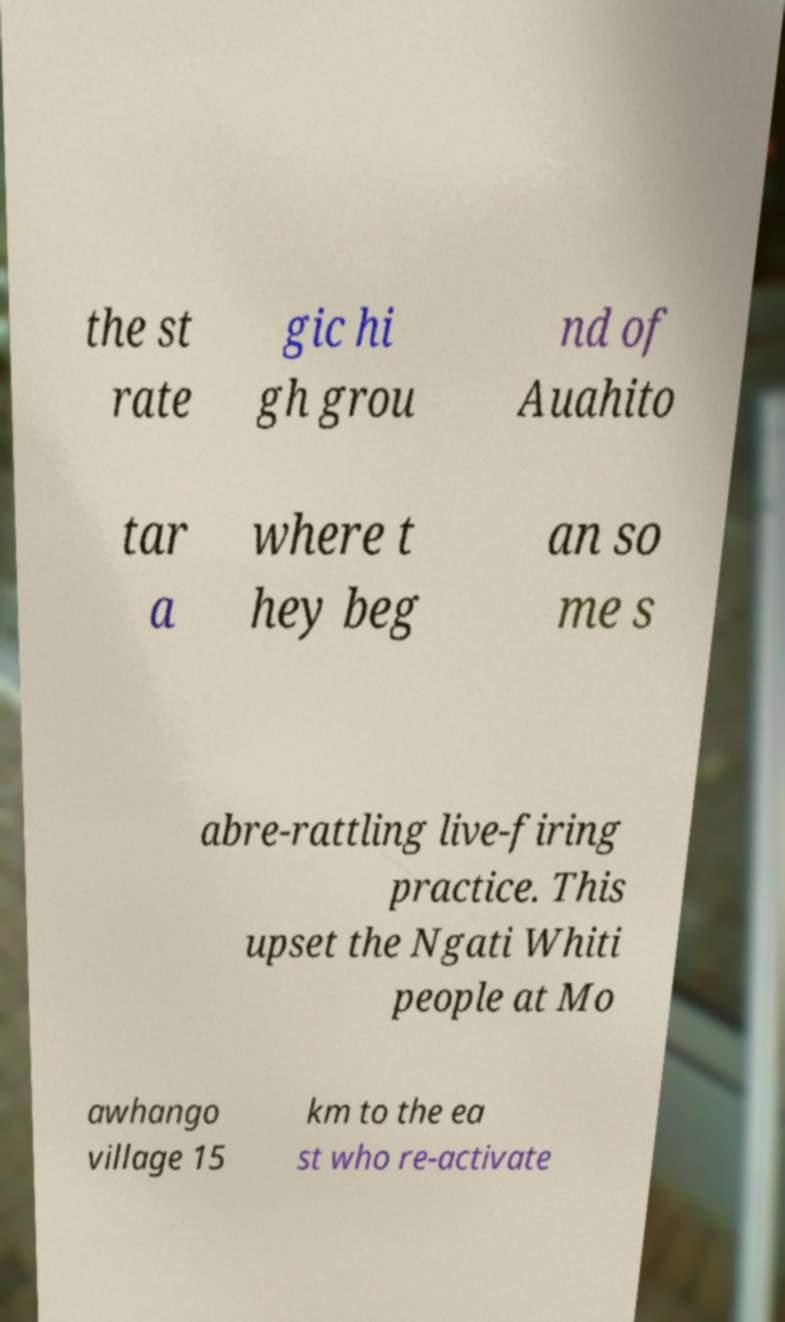What messages or text are displayed in this image? I need them in a readable, typed format. the st rate gic hi gh grou nd of Auahito tar a where t hey beg an so me s abre-rattling live-firing practice. This upset the Ngati Whiti people at Mo awhango village 15 km to the ea st who re-activate 